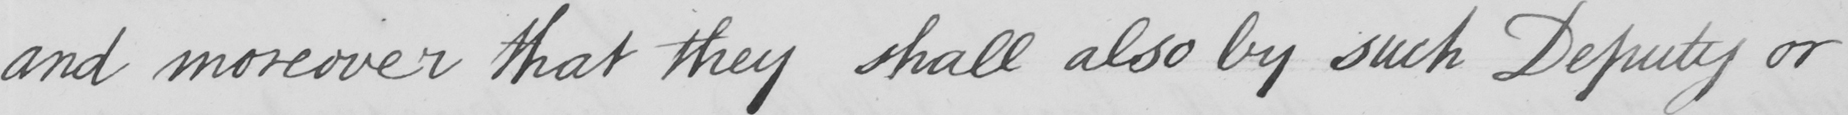Please provide the text content of this handwritten line. and moreover that they shall also by such Deputy or 